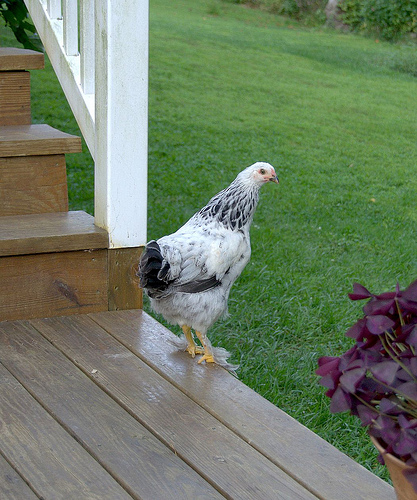<image>
Can you confirm if the chicken is above the porch? Yes. The chicken is positioned above the porch in the vertical space, higher up in the scene. 